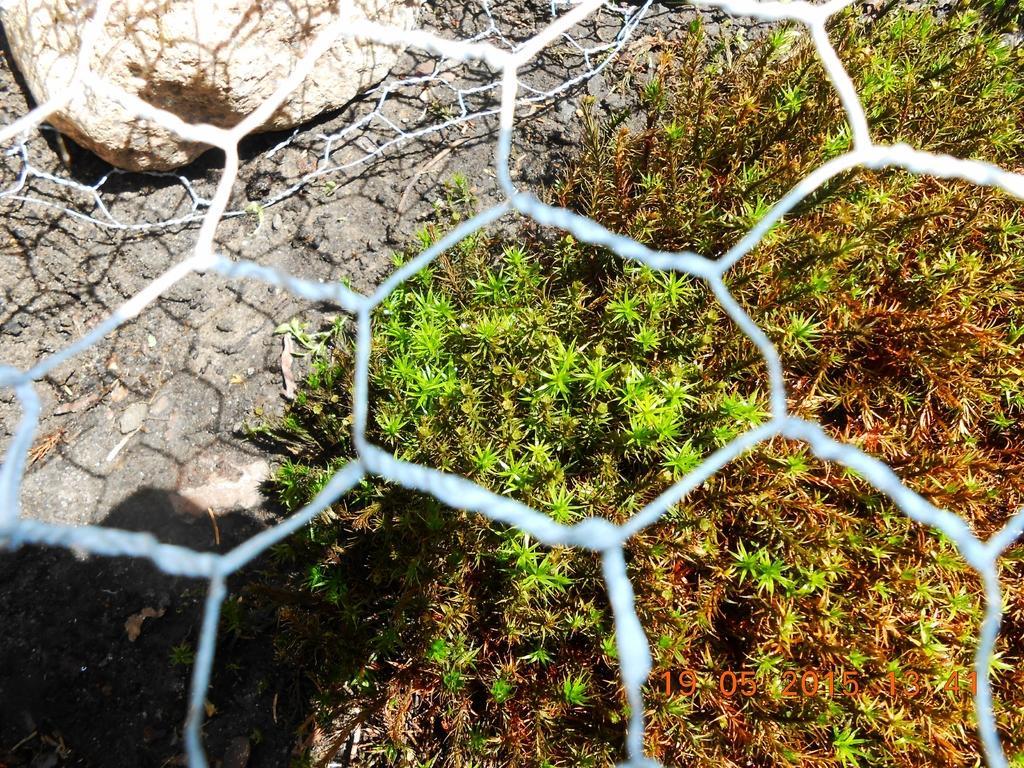Could you give a brief overview of what you see in this image? In this image, we can see a mesh and through the mesh we can see some plants on the ground and there is a rock. 